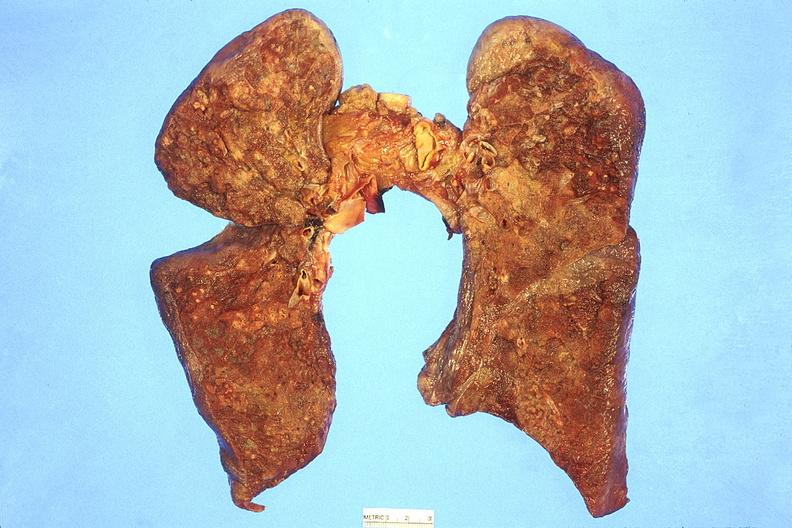does iron show lung, abscesses?
Answer the question using a single word or phrase. No 